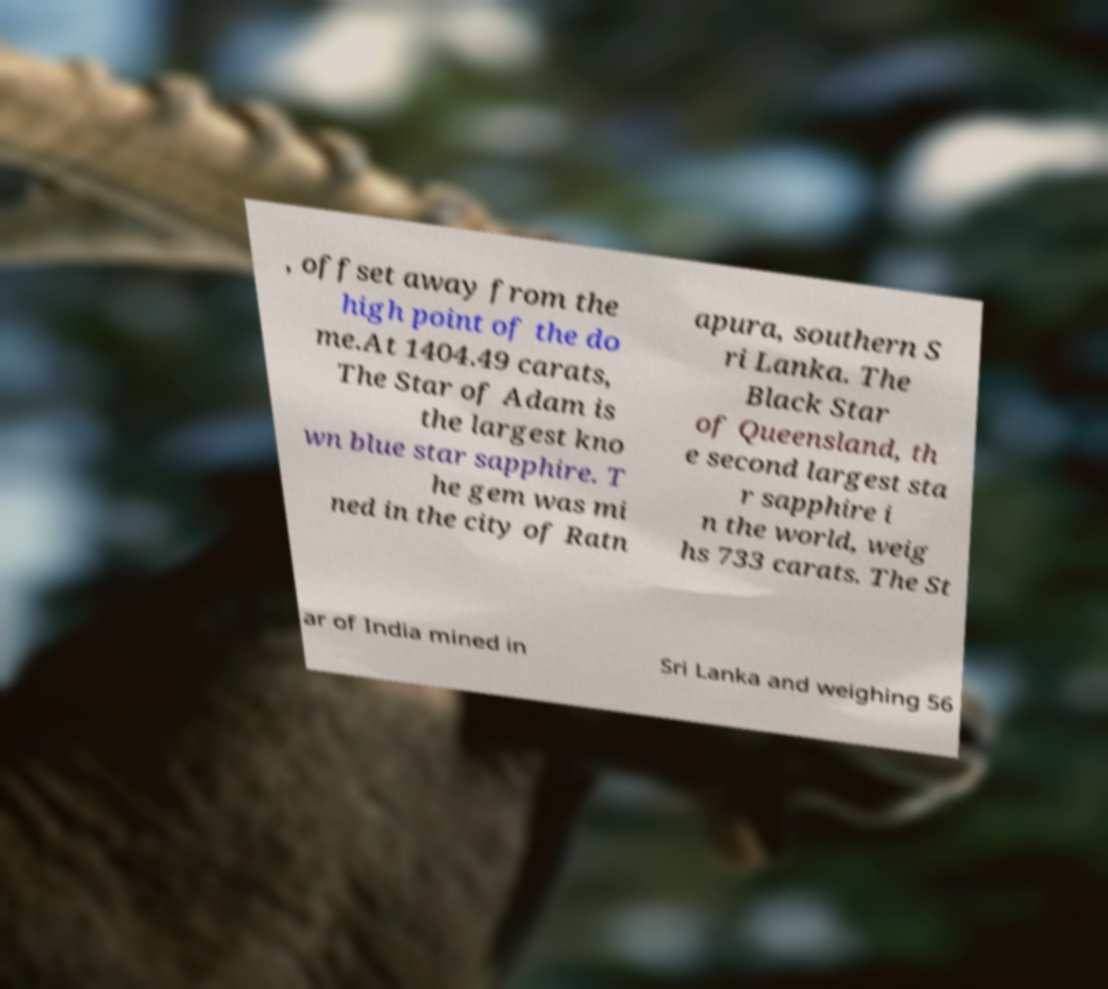Please read and relay the text visible in this image. What does it say? , offset away from the high point of the do me.At 1404.49 carats, The Star of Adam is the largest kno wn blue star sapphire. T he gem was mi ned in the city of Ratn apura, southern S ri Lanka. The Black Star of Queensland, th e second largest sta r sapphire i n the world, weig hs 733 carats. The St ar of India mined in Sri Lanka and weighing 56 